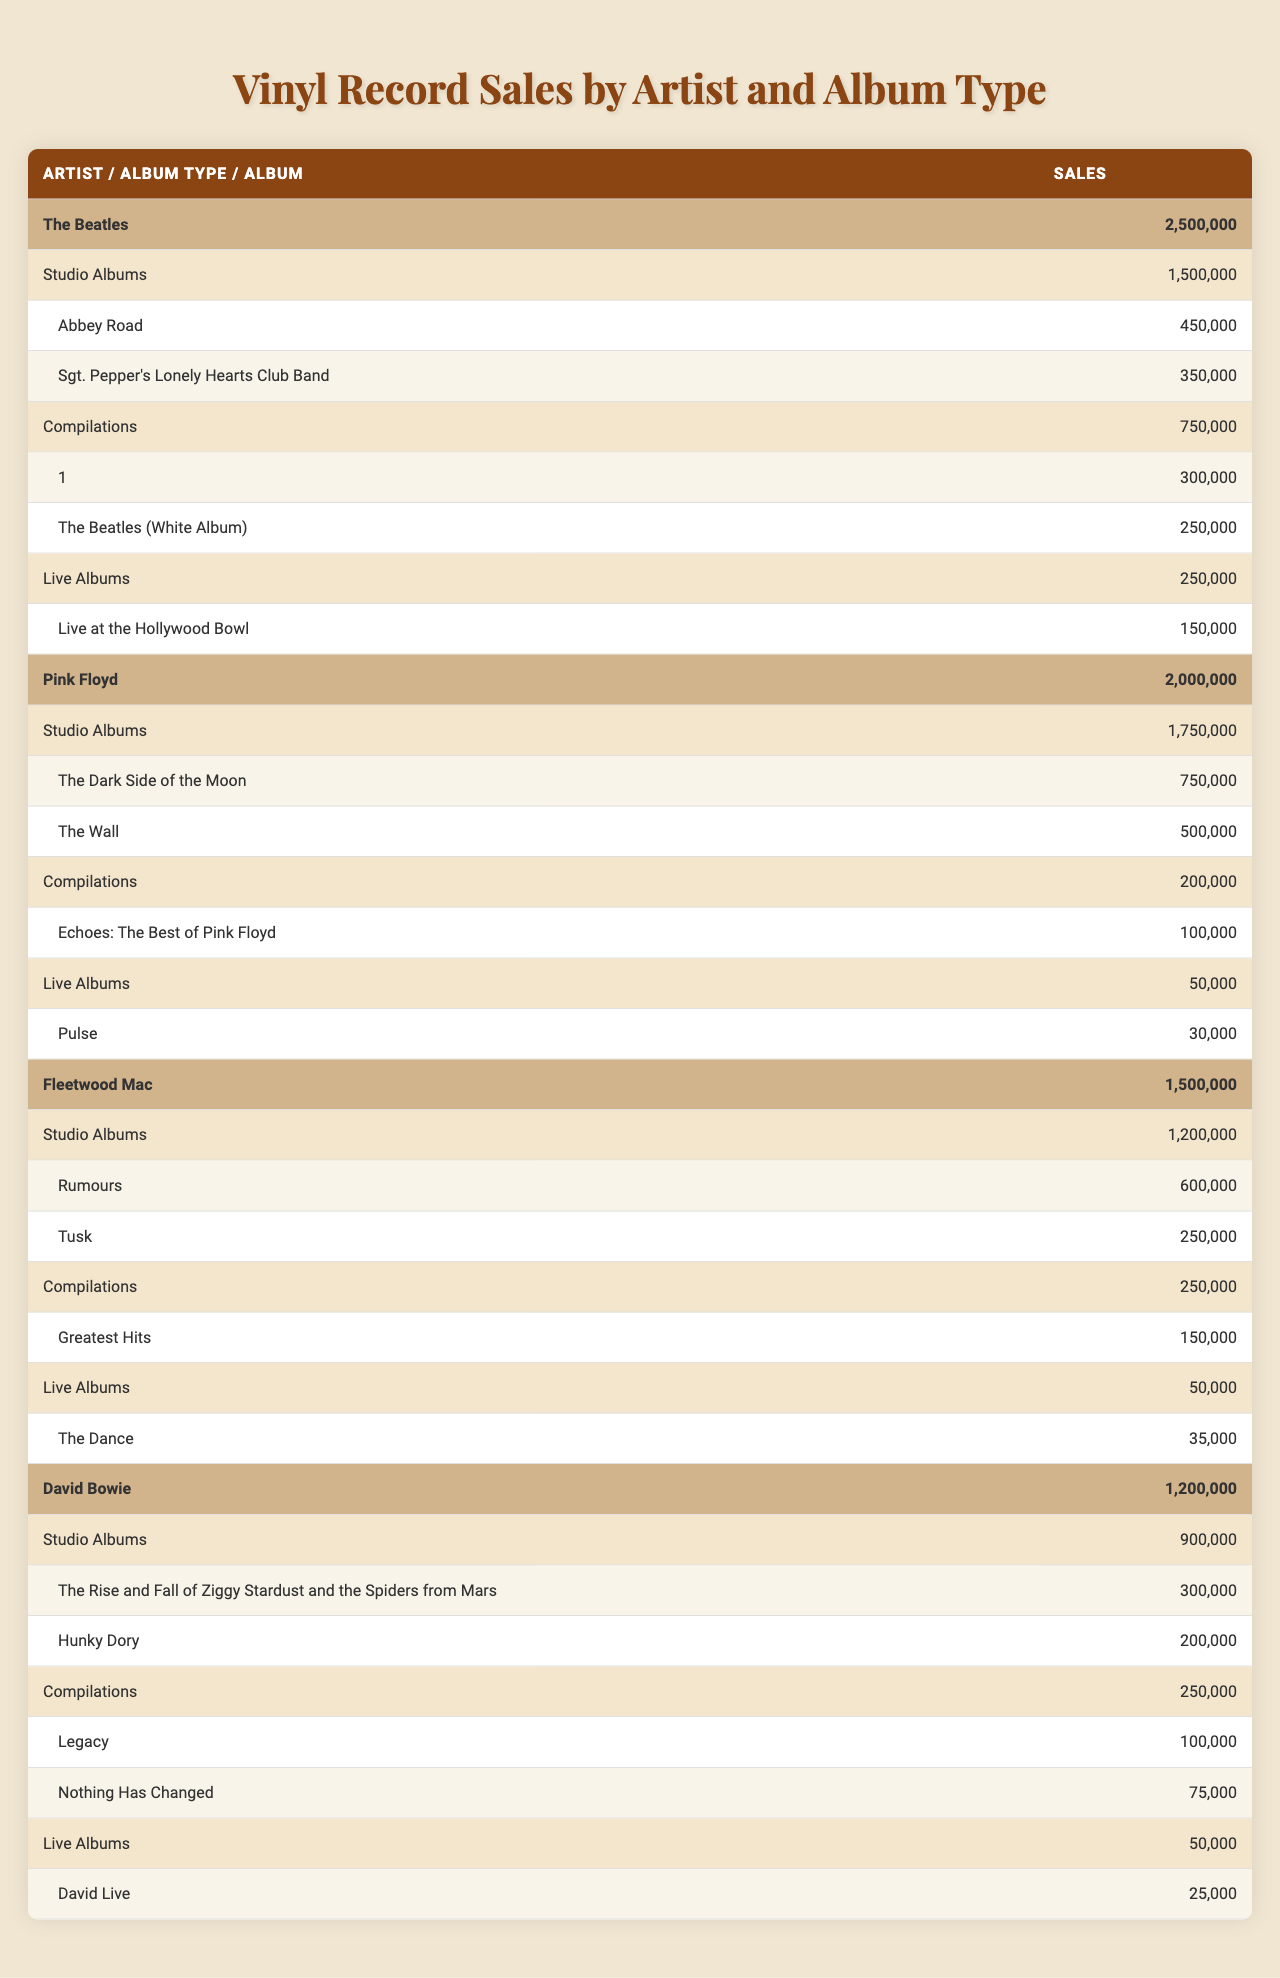What is the total vinyl record sales for The Beatles? The total sales for The Beatles is listed in the table under Total Sales, which shows 2,500,000.
Answer: 2,500,000 Which artist has the highest sales from studio albums? To find the artist with the highest studio album sales, we look at the Studio Albums row for each artist. The highest is Pink Floyd with 1,750,000.
Answer: Pink Floyd How much did David Bowie's compilations sell? In the table, under David Bowie's Album Types, the Compilations row shows sales of 250,000.
Answer: 250,000 Which album is the top seller for Fleetwood Mac and what are its sales? The top seller for Fleetwood Mac is "Rumours" with sales of 600,000, as indicated in the Studio Albums section.
Answer: Rumours, 600,000 What is the total number of sales for live albums across all artists? To find the total live album sales, we sum the sales from the Live Albums rows for each artist: 250,000 (The Beatles) + 50,000 (Pink Floyd) + 50,000 (Fleetwood Mac) + 50,000 (David Bowie) = 400,000.
Answer: 400,000 Do any albums from David Bowie's compilations exceed 100,000 in sales? Checking the Top Sellers in the Compilations section, "Legacy" sold 100,000, and "Nothing Has Changed" sold 75,000. Since 100,000 is not exceeded, the answer is no.
Answer: No Which artist has the lowest total sales? We need to compare the total sales for all artists: The Beatles (2,500,000), Pink Floyd (2,000,000), Fleetwood Mac (1,500,000), and David Bowie (1,200,000). The lowest is David Bowie.
Answer: David Bowie What is the difference in total sales between The Beatles and Pink Floyd? The total sales for The Beatles is 2,500,000 and for Pink Floyd is 2,000,000. The difference is 2,500,000 - 2,000,000 = 500,000.
Answer: 500,000 Are compilations more popular than live albums for Fleetwood Mac? Fleetwood Mac's Compilations sales are 250,000 and Live Albums sales are 50,000. Since 250,000 > 50,000, compilations are indeed more popular.
Answer: Yes Which album type accounts for the most sales for Pink Floyd? Reviewing the Album Types for Pink Floyd, Studio Albums sold 1,750,000, Compilations 200,000, and Live Albums 50,000. The highest sales belong to Studio Albums.
Answer: Studio Albums 